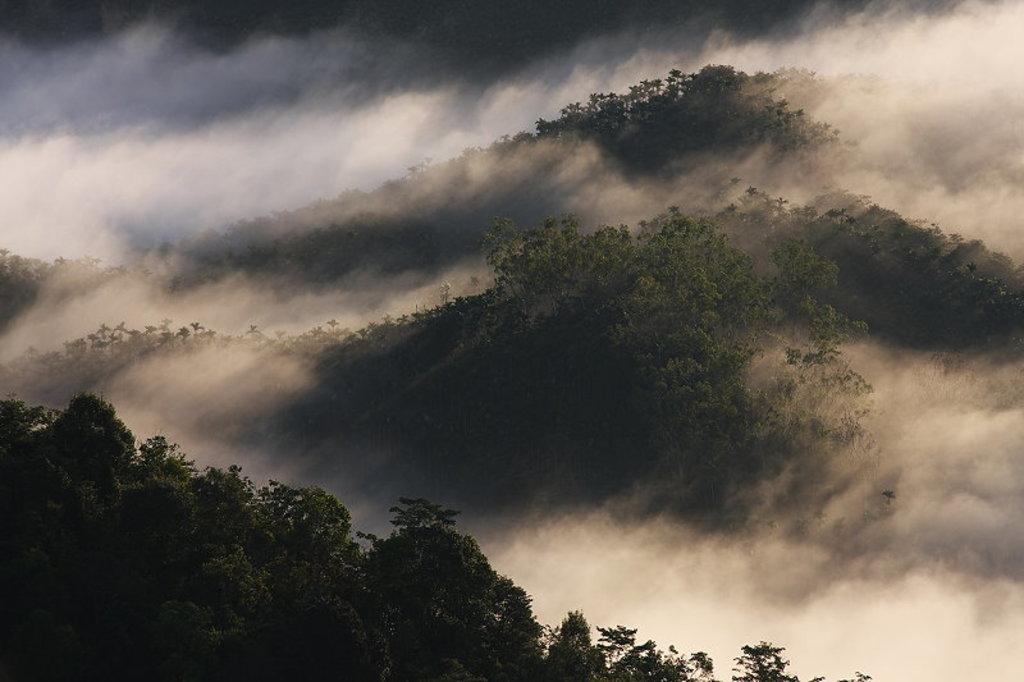What type of landscape is depicted in the image? The image features hills. Are there any plants or vegetation on the hills? Yes, the hills have trees on them. What is the weather or atmospheric condition in the image? The hills are covered with fog. How many bikes are parked on the neck of the hill in the image? There are no bikes present in the image, and the hills do not have a neck. 